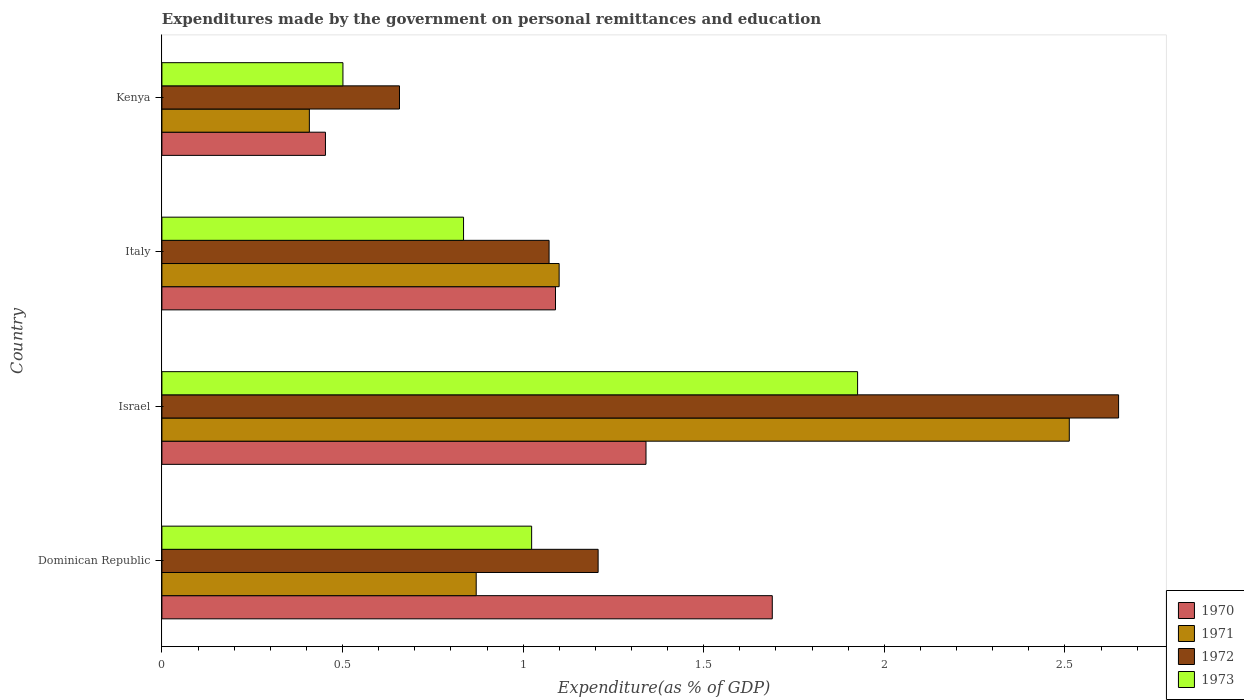How many different coloured bars are there?
Your answer should be very brief. 4. How many groups of bars are there?
Provide a short and direct response. 4. Are the number of bars per tick equal to the number of legend labels?
Give a very brief answer. Yes. Are the number of bars on each tick of the Y-axis equal?
Make the answer very short. Yes. How many bars are there on the 4th tick from the bottom?
Offer a terse response. 4. What is the expenditures made by the government on personal remittances and education in 1973 in Italy?
Your answer should be very brief. 0.84. Across all countries, what is the maximum expenditures made by the government on personal remittances and education in 1972?
Ensure brevity in your answer.  2.65. Across all countries, what is the minimum expenditures made by the government on personal remittances and education in 1970?
Give a very brief answer. 0.45. In which country was the expenditures made by the government on personal remittances and education in 1972 minimum?
Provide a short and direct response. Kenya. What is the total expenditures made by the government on personal remittances and education in 1971 in the graph?
Give a very brief answer. 4.89. What is the difference between the expenditures made by the government on personal remittances and education in 1973 in Israel and that in Kenya?
Your answer should be very brief. 1.42. What is the difference between the expenditures made by the government on personal remittances and education in 1973 in Italy and the expenditures made by the government on personal remittances and education in 1972 in Kenya?
Your answer should be very brief. 0.18. What is the average expenditures made by the government on personal remittances and education in 1973 per country?
Offer a terse response. 1.07. What is the difference between the expenditures made by the government on personal remittances and education in 1971 and expenditures made by the government on personal remittances and education in 1972 in Italy?
Offer a very short reply. 0.03. In how many countries, is the expenditures made by the government on personal remittances and education in 1972 greater than 0.6 %?
Ensure brevity in your answer.  4. What is the ratio of the expenditures made by the government on personal remittances and education in 1971 in Israel to that in Italy?
Offer a terse response. 2.28. Is the difference between the expenditures made by the government on personal remittances and education in 1971 in Dominican Republic and Kenya greater than the difference between the expenditures made by the government on personal remittances and education in 1972 in Dominican Republic and Kenya?
Offer a terse response. No. What is the difference between the highest and the second highest expenditures made by the government on personal remittances and education in 1970?
Your answer should be very brief. 0.35. What is the difference between the highest and the lowest expenditures made by the government on personal remittances and education in 1972?
Your answer should be very brief. 1.99. In how many countries, is the expenditures made by the government on personal remittances and education in 1970 greater than the average expenditures made by the government on personal remittances and education in 1970 taken over all countries?
Your response must be concise. 2. Is the sum of the expenditures made by the government on personal remittances and education in 1972 in Israel and Italy greater than the maximum expenditures made by the government on personal remittances and education in 1973 across all countries?
Provide a short and direct response. Yes. Is it the case that in every country, the sum of the expenditures made by the government on personal remittances and education in 1972 and expenditures made by the government on personal remittances and education in 1970 is greater than the sum of expenditures made by the government on personal remittances and education in 1973 and expenditures made by the government on personal remittances and education in 1971?
Your answer should be very brief. No. Is it the case that in every country, the sum of the expenditures made by the government on personal remittances and education in 1970 and expenditures made by the government on personal remittances and education in 1972 is greater than the expenditures made by the government on personal remittances and education in 1971?
Offer a very short reply. Yes. How many bars are there?
Offer a terse response. 16. Are all the bars in the graph horizontal?
Ensure brevity in your answer.  Yes. How many countries are there in the graph?
Ensure brevity in your answer.  4. What is the difference between two consecutive major ticks on the X-axis?
Offer a very short reply. 0.5. Are the values on the major ticks of X-axis written in scientific E-notation?
Provide a short and direct response. No. Does the graph contain any zero values?
Offer a terse response. No. Where does the legend appear in the graph?
Provide a succinct answer. Bottom right. How many legend labels are there?
Make the answer very short. 4. What is the title of the graph?
Keep it short and to the point. Expenditures made by the government on personal remittances and education. What is the label or title of the X-axis?
Your answer should be compact. Expenditure(as % of GDP). What is the Expenditure(as % of GDP) of 1970 in Dominican Republic?
Give a very brief answer. 1.69. What is the Expenditure(as % of GDP) of 1971 in Dominican Republic?
Offer a terse response. 0.87. What is the Expenditure(as % of GDP) of 1972 in Dominican Republic?
Your answer should be compact. 1.21. What is the Expenditure(as % of GDP) of 1973 in Dominican Republic?
Give a very brief answer. 1.02. What is the Expenditure(as % of GDP) in 1970 in Israel?
Offer a very short reply. 1.34. What is the Expenditure(as % of GDP) in 1971 in Israel?
Make the answer very short. 2.51. What is the Expenditure(as % of GDP) of 1972 in Israel?
Give a very brief answer. 2.65. What is the Expenditure(as % of GDP) of 1973 in Israel?
Your answer should be compact. 1.93. What is the Expenditure(as % of GDP) in 1970 in Italy?
Your answer should be very brief. 1.09. What is the Expenditure(as % of GDP) of 1971 in Italy?
Ensure brevity in your answer.  1.1. What is the Expenditure(as % of GDP) of 1972 in Italy?
Your response must be concise. 1.07. What is the Expenditure(as % of GDP) in 1973 in Italy?
Give a very brief answer. 0.84. What is the Expenditure(as % of GDP) of 1970 in Kenya?
Give a very brief answer. 0.45. What is the Expenditure(as % of GDP) in 1971 in Kenya?
Your response must be concise. 0.41. What is the Expenditure(as % of GDP) of 1972 in Kenya?
Make the answer very short. 0.66. What is the Expenditure(as % of GDP) of 1973 in Kenya?
Provide a succinct answer. 0.5. Across all countries, what is the maximum Expenditure(as % of GDP) of 1970?
Provide a succinct answer. 1.69. Across all countries, what is the maximum Expenditure(as % of GDP) of 1971?
Your answer should be very brief. 2.51. Across all countries, what is the maximum Expenditure(as % of GDP) in 1972?
Ensure brevity in your answer.  2.65. Across all countries, what is the maximum Expenditure(as % of GDP) in 1973?
Ensure brevity in your answer.  1.93. Across all countries, what is the minimum Expenditure(as % of GDP) of 1970?
Give a very brief answer. 0.45. Across all countries, what is the minimum Expenditure(as % of GDP) in 1971?
Provide a short and direct response. 0.41. Across all countries, what is the minimum Expenditure(as % of GDP) in 1972?
Ensure brevity in your answer.  0.66. Across all countries, what is the minimum Expenditure(as % of GDP) of 1973?
Offer a terse response. 0.5. What is the total Expenditure(as % of GDP) of 1970 in the graph?
Your response must be concise. 4.57. What is the total Expenditure(as % of GDP) of 1971 in the graph?
Provide a short and direct response. 4.89. What is the total Expenditure(as % of GDP) in 1972 in the graph?
Make the answer very short. 5.59. What is the total Expenditure(as % of GDP) of 1973 in the graph?
Give a very brief answer. 4.29. What is the difference between the Expenditure(as % of GDP) of 1970 in Dominican Republic and that in Israel?
Provide a succinct answer. 0.35. What is the difference between the Expenditure(as % of GDP) of 1971 in Dominican Republic and that in Israel?
Offer a terse response. -1.64. What is the difference between the Expenditure(as % of GDP) of 1972 in Dominican Republic and that in Israel?
Your answer should be very brief. -1.44. What is the difference between the Expenditure(as % of GDP) of 1973 in Dominican Republic and that in Israel?
Ensure brevity in your answer.  -0.9. What is the difference between the Expenditure(as % of GDP) of 1970 in Dominican Republic and that in Italy?
Make the answer very short. 0.6. What is the difference between the Expenditure(as % of GDP) in 1971 in Dominican Republic and that in Italy?
Make the answer very short. -0.23. What is the difference between the Expenditure(as % of GDP) of 1972 in Dominican Republic and that in Italy?
Keep it short and to the point. 0.14. What is the difference between the Expenditure(as % of GDP) in 1973 in Dominican Republic and that in Italy?
Offer a very short reply. 0.19. What is the difference between the Expenditure(as % of GDP) of 1970 in Dominican Republic and that in Kenya?
Your answer should be very brief. 1.24. What is the difference between the Expenditure(as % of GDP) of 1971 in Dominican Republic and that in Kenya?
Provide a succinct answer. 0.46. What is the difference between the Expenditure(as % of GDP) of 1972 in Dominican Republic and that in Kenya?
Your answer should be very brief. 0.55. What is the difference between the Expenditure(as % of GDP) of 1973 in Dominican Republic and that in Kenya?
Offer a terse response. 0.52. What is the difference between the Expenditure(as % of GDP) in 1970 in Israel and that in Italy?
Offer a very short reply. 0.25. What is the difference between the Expenditure(as % of GDP) in 1971 in Israel and that in Italy?
Your answer should be very brief. 1.41. What is the difference between the Expenditure(as % of GDP) in 1972 in Israel and that in Italy?
Ensure brevity in your answer.  1.58. What is the difference between the Expenditure(as % of GDP) in 1970 in Israel and that in Kenya?
Your answer should be very brief. 0.89. What is the difference between the Expenditure(as % of GDP) of 1971 in Israel and that in Kenya?
Your answer should be compact. 2.1. What is the difference between the Expenditure(as % of GDP) in 1972 in Israel and that in Kenya?
Ensure brevity in your answer.  1.99. What is the difference between the Expenditure(as % of GDP) in 1973 in Israel and that in Kenya?
Make the answer very short. 1.42. What is the difference between the Expenditure(as % of GDP) of 1970 in Italy and that in Kenya?
Your answer should be compact. 0.64. What is the difference between the Expenditure(as % of GDP) of 1971 in Italy and that in Kenya?
Your answer should be compact. 0.69. What is the difference between the Expenditure(as % of GDP) of 1972 in Italy and that in Kenya?
Your response must be concise. 0.41. What is the difference between the Expenditure(as % of GDP) of 1973 in Italy and that in Kenya?
Give a very brief answer. 0.33. What is the difference between the Expenditure(as % of GDP) of 1970 in Dominican Republic and the Expenditure(as % of GDP) of 1971 in Israel?
Offer a terse response. -0.82. What is the difference between the Expenditure(as % of GDP) in 1970 in Dominican Republic and the Expenditure(as % of GDP) in 1972 in Israel?
Keep it short and to the point. -0.96. What is the difference between the Expenditure(as % of GDP) of 1970 in Dominican Republic and the Expenditure(as % of GDP) of 1973 in Israel?
Ensure brevity in your answer.  -0.24. What is the difference between the Expenditure(as % of GDP) in 1971 in Dominican Republic and the Expenditure(as % of GDP) in 1972 in Israel?
Ensure brevity in your answer.  -1.78. What is the difference between the Expenditure(as % of GDP) in 1971 in Dominican Republic and the Expenditure(as % of GDP) in 1973 in Israel?
Your answer should be compact. -1.06. What is the difference between the Expenditure(as % of GDP) of 1972 in Dominican Republic and the Expenditure(as % of GDP) of 1973 in Israel?
Provide a succinct answer. -0.72. What is the difference between the Expenditure(as % of GDP) in 1970 in Dominican Republic and the Expenditure(as % of GDP) in 1971 in Italy?
Give a very brief answer. 0.59. What is the difference between the Expenditure(as % of GDP) of 1970 in Dominican Republic and the Expenditure(as % of GDP) of 1972 in Italy?
Make the answer very short. 0.62. What is the difference between the Expenditure(as % of GDP) in 1970 in Dominican Republic and the Expenditure(as % of GDP) in 1973 in Italy?
Provide a succinct answer. 0.85. What is the difference between the Expenditure(as % of GDP) in 1971 in Dominican Republic and the Expenditure(as % of GDP) in 1972 in Italy?
Your answer should be very brief. -0.2. What is the difference between the Expenditure(as % of GDP) in 1971 in Dominican Republic and the Expenditure(as % of GDP) in 1973 in Italy?
Offer a very short reply. 0.04. What is the difference between the Expenditure(as % of GDP) of 1972 in Dominican Republic and the Expenditure(as % of GDP) of 1973 in Italy?
Give a very brief answer. 0.37. What is the difference between the Expenditure(as % of GDP) of 1970 in Dominican Republic and the Expenditure(as % of GDP) of 1971 in Kenya?
Provide a short and direct response. 1.28. What is the difference between the Expenditure(as % of GDP) of 1970 in Dominican Republic and the Expenditure(as % of GDP) of 1972 in Kenya?
Keep it short and to the point. 1.03. What is the difference between the Expenditure(as % of GDP) of 1970 in Dominican Republic and the Expenditure(as % of GDP) of 1973 in Kenya?
Give a very brief answer. 1.19. What is the difference between the Expenditure(as % of GDP) of 1971 in Dominican Republic and the Expenditure(as % of GDP) of 1972 in Kenya?
Ensure brevity in your answer.  0.21. What is the difference between the Expenditure(as % of GDP) of 1971 in Dominican Republic and the Expenditure(as % of GDP) of 1973 in Kenya?
Offer a terse response. 0.37. What is the difference between the Expenditure(as % of GDP) in 1972 in Dominican Republic and the Expenditure(as % of GDP) in 1973 in Kenya?
Offer a very short reply. 0.71. What is the difference between the Expenditure(as % of GDP) of 1970 in Israel and the Expenditure(as % of GDP) of 1971 in Italy?
Give a very brief answer. 0.24. What is the difference between the Expenditure(as % of GDP) in 1970 in Israel and the Expenditure(as % of GDP) in 1972 in Italy?
Give a very brief answer. 0.27. What is the difference between the Expenditure(as % of GDP) of 1970 in Israel and the Expenditure(as % of GDP) of 1973 in Italy?
Your response must be concise. 0.51. What is the difference between the Expenditure(as % of GDP) of 1971 in Israel and the Expenditure(as % of GDP) of 1972 in Italy?
Provide a short and direct response. 1.44. What is the difference between the Expenditure(as % of GDP) of 1971 in Israel and the Expenditure(as % of GDP) of 1973 in Italy?
Make the answer very short. 1.68. What is the difference between the Expenditure(as % of GDP) of 1972 in Israel and the Expenditure(as % of GDP) of 1973 in Italy?
Give a very brief answer. 1.81. What is the difference between the Expenditure(as % of GDP) of 1970 in Israel and the Expenditure(as % of GDP) of 1971 in Kenya?
Make the answer very short. 0.93. What is the difference between the Expenditure(as % of GDP) in 1970 in Israel and the Expenditure(as % of GDP) in 1972 in Kenya?
Ensure brevity in your answer.  0.68. What is the difference between the Expenditure(as % of GDP) in 1970 in Israel and the Expenditure(as % of GDP) in 1973 in Kenya?
Keep it short and to the point. 0.84. What is the difference between the Expenditure(as % of GDP) of 1971 in Israel and the Expenditure(as % of GDP) of 1972 in Kenya?
Keep it short and to the point. 1.85. What is the difference between the Expenditure(as % of GDP) of 1971 in Israel and the Expenditure(as % of GDP) of 1973 in Kenya?
Ensure brevity in your answer.  2.01. What is the difference between the Expenditure(as % of GDP) of 1972 in Israel and the Expenditure(as % of GDP) of 1973 in Kenya?
Ensure brevity in your answer.  2.15. What is the difference between the Expenditure(as % of GDP) of 1970 in Italy and the Expenditure(as % of GDP) of 1971 in Kenya?
Offer a very short reply. 0.68. What is the difference between the Expenditure(as % of GDP) in 1970 in Italy and the Expenditure(as % of GDP) in 1972 in Kenya?
Your answer should be very brief. 0.43. What is the difference between the Expenditure(as % of GDP) of 1970 in Italy and the Expenditure(as % of GDP) of 1973 in Kenya?
Give a very brief answer. 0.59. What is the difference between the Expenditure(as % of GDP) in 1971 in Italy and the Expenditure(as % of GDP) in 1972 in Kenya?
Keep it short and to the point. 0.44. What is the difference between the Expenditure(as % of GDP) in 1971 in Italy and the Expenditure(as % of GDP) in 1973 in Kenya?
Offer a terse response. 0.6. What is the difference between the Expenditure(as % of GDP) in 1972 in Italy and the Expenditure(as % of GDP) in 1973 in Kenya?
Your answer should be compact. 0.57. What is the average Expenditure(as % of GDP) of 1970 per country?
Ensure brevity in your answer.  1.14. What is the average Expenditure(as % of GDP) of 1971 per country?
Ensure brevity in your answer.  1.22. What is the average Expenditure(as % of GDP) of 1972 per country?
Give a very brief answer. 1.4. What is the average Expenditure(as % of GDP) of 1973 per country?
Provide a short and direct response. 1.07. What is the difference between the Expenditure(as % of GDP) in 1970 and Expenditure(as % of GDP) in 1971 in Dominican Republic?
Give a very brief answer. 0.82. What is the difference between the Expenditure(as % of GDP) of 1970 and Expenditure(as % of GDP) of 1972 in Dominican Republic?
Your response must be concise. 0.48. What is the difference between the Expenditure(as % of GDP) in 1970 and Expenditure(as % of GDP) in 1973 in Dominican Republic?
Provide a short and direct response. 0.67. What is the difference between the Expenditure(as % of GDP) of 1971 and Expenditure(as % of GDP) of 1972 in Dominican Republic?
Your response must be concise. -0.34. What is the difference between the Expenditure(as % of GDP) of 1971 and Expenditure(as % of GDP) of 1973 in Dominican Republic?
Your answer should be compact. -0.15. What is the difference between the Expenditure(as % of GDP) of 1972 and Expenditure(as % of GDP) of 1973 in Dominican Republic?
Offer a very short reply. 0.18. What is the difference between the Expenditure(as % of GDP) in 1970 and Expenditure(as % of GDP) in 1971 in Israel?
Provide a succinct answer. -1.17. What is the difference between the Expenditure(as % of GDP) of 1970 and Expenditure(as % of GDP) of 1972 in Israel?
Offer a terse response. -1.31. What is the difference between the Expenditure(as % of GDP) of 1970 and Expenditure(as % of GDP) of 1973 in Israel?
Provide a short and direct response. -0.59. What is the difference between the Expenditure(as % of GDP) in 1971 and Expenditure(as % of GDP) in 1972 in Israel?
Provide a short and direct response. -0.14. What is the difference between the Expenditure(as % of GDP) of 1971 and Expenditure(as % of GDP) of 1973 in Israel?
Your answer should be very brief. 0.59. What is the difference between the Expenditure(as % of GDP) of 1972 and Expenditure(as % of GDP) of 1973 in Israel?
Provide a succinct answer. 0.72. What is the difference between the Expenditure(as % of GDP) of 1970 and Expenditure(as % of GDP) of 1971 in Italy?
Your answer should be very brief. -0.01. What is the difference between the Expenditure(as % of GDP) of 1970 and Expenditure(as % of GDP) of 1972 in Italy?
Your answer should be compact. 0.02. What is the difference between the Expenditure(as % of GDP) of 1970 and Expenditure(as % of GDP) of 1973 in Italy?
Make the answer very short. 0.25. What is the difference between the Expenditure(as % of GDP) in 1971 and Expenditure(as % of GDP) in 1972 in Italy?
Your answer should be very brief. 0.03. What is the difference between the Expenditure(as % of GDP) in 1971 and Expenditure(as % of GDP) in 1973 in Italy?
Your response must be concise. 0.26. What is the difference between the Expenditure(as % of GDP) in 1972 and Expenditure(as % of GDP) in 1973 in Italy?
Your answer should be compact. 0.24. What is the difference between the Expenditure(as % of GDP) in 1970 and Expenditure(as % of GDP) in 1971 in Kenya?
Your answer should be very brief. 0.04. What is the difference between the Expenditure(as % of GDP) of 1970 and Expenditure(as % of GDP) of 1972 in Kenya?
Offer a very short reply. -0.2. What is the difference between the Expenditure(as % of GDP) of 1970 and Expenditure(as % of GDP) of 1973 in Kenya?
Provide a short and direct response. -0.05. What is the difference between the Expenditure(as % of GDP) of 1971 and Expenditure(as % of GDP) of 1972 in Kenya?
Your response must be concise. -0.25. What is the difference between the Expenditure(as % of GDP) in 1971 and Expenditure(as % of GDP) in 1973 in Kenya?
Keep it short and to the point. -0.09. What is the difference between the Expenditure(as % of GDP) in 1972 and Expenditure(as % of GDP) in 1973 in Kenya?
Provide a succinct answer. 0.16. What is the ratio of the Expenditure(as % of GDP) in 1970 in Dominican Republic to that in Israel?
Your answer should be very brief. 1.26. What is the ratio of the Expenditure(as % of GDP) in 1971 in Dominican Republic to that in Israel?
Provide a short and direct response. 0.35. What is the ratio of the Expenditure(as % of GDP) of 1972 in Dominican Republic to that in Israel?
Your response must be concise. 0.46. What is the ratio of the Expenditure(as % of GDP) of 1973 in Dominican Republic to that in Israel?
Your answer should be compact. 0.53. What is the ratio of the Expenditure(as % of GDP) in 1970 in Dominican Republic to that in Italy?
Give a very brief answer. 1.55. What is the ratio of the Expenditure(as % of GDP) of 1971 in Dominican Republic to that in Italy?
Your response must be concise. 0.79. What is the ratio of the Expenditure(as % of GDP) in 1972 in Dominican Republic to that in Italy?
Your response must be concise. 1.13. What is the ratio of the Expenditure(as % of GDP) in 1973 in Dominican Republic to that in Italy?
Offer a very short reply. 1.23. What is the ratio of the Expenditure(as % of GDP) of 1970 in Dominican Republic to that in Kenya?
Provide a short and direct response. 3.73. What is the ratio of the Expenditure(as % of GDP) in 1971 in Dominican Republic to that in Kenya?
Your response must be concise. 2.13. What is the ratio of the Expenditure(as % of GDP) of 1972 in Dominican Republic to that in Kenya?
Offer a terse response. 1.84. What is the ratio of the Expenditure(as % of GDP) in 1973 in Dominican Republic to that in Kenya?
Offer a very short reply. 2.04. What is the ratio of the Expenditure(as % of GDP) of 1970 in Israel to that in Italy?
Keep it short and to the point. 1.23. What is the ratio of the Expenditure(as % of GDP) in 1971 in Israel to that in Italy?
Provide a short and direct response. 2.28. What is the ratio of the Expenditure(as % of GDP) of 1972 in Israel to that in Italy?
Give a very brief answer. 2.47. What is the ratio of the Expenditure(as % of GDP) of 1973 in Israel to that in Italy?
Provide a short and direct response. 2.31. What is the ratio of the Expenditure(as % of GDP) in 1970 in Israel to that in Kenya?
Offer a very short reply. 2.96. What is the ratio of the Expenditure(as % of GDP) in 1971 in Israel to that in Kenya?
Ensure brevity in your answer.  6.15. What is the ratio of the Expenditure(as % of GDP) in 1972 in Israel to that in Kenya?
Offer a very short reply. 4.03. What is the ratio of the Expenditure(as % of GDP) in 1973 in Israel to that in Kenya?
Offer a very short reply. 3.84. What is the ratio of the Expenditure(as % of GDP) in 1970 in Italy to that in Kenya?
Make the answer very short. 2.41. What is the ratio of the Expenditure(as % of GDP) of 1971 in Italy to that in Kenya?
Provide a short and direct response. 2.69. What is the ratio of the Expenditure(as % of GDP) of 1972 in Italy to that in Kenya?
Make the answer very short. 1.63. What is the ratio of the Expenditure(as % of GDP) of 1973 in Italy to that in Kenya?
Ensure brevity in your answer.  1.67. What is the difference between the highest and the second highest Expenditure(as % of GDP) of 1970?
Make the answer very short. 0.35. What is the difference between the highest and the second highest Expenditure(as % of GDP) in 1971?
Offer a terse response. 1.41. What is the difference between the highest and the second highest Expenditure(as % of GDP) of 1972?
Make the answer very short. 1.44. What is the difference between the highest and the second highest Expenditure(as % of GDP) of 1973?
Your answer should be compact. 0.9. What is the difference between the highest and the lowest Expenditure(as % of GDP) in 1970?
Offer a terse response. 1.24. What is the difference between the highest and the lowest Expenditure(as % of GDP) of 1971?
Give a very brief answer. 2.1. What is the difference between the highest and the lowest Expenditure(as % of GDP) of 1972?
Offer a terse response. 1.99. What is the difference between the highest and the lowest Expenditure(as % of GDP) of 1973?
Provide a succinct answer. 1.42. 